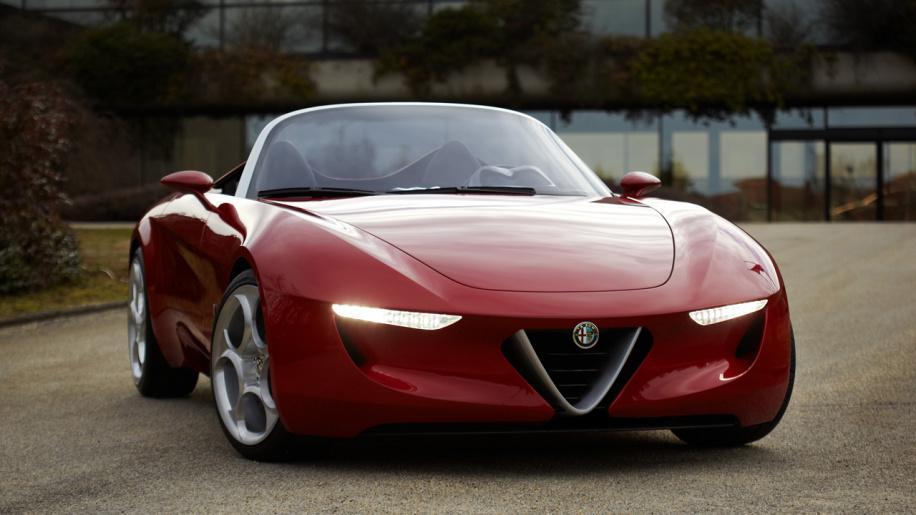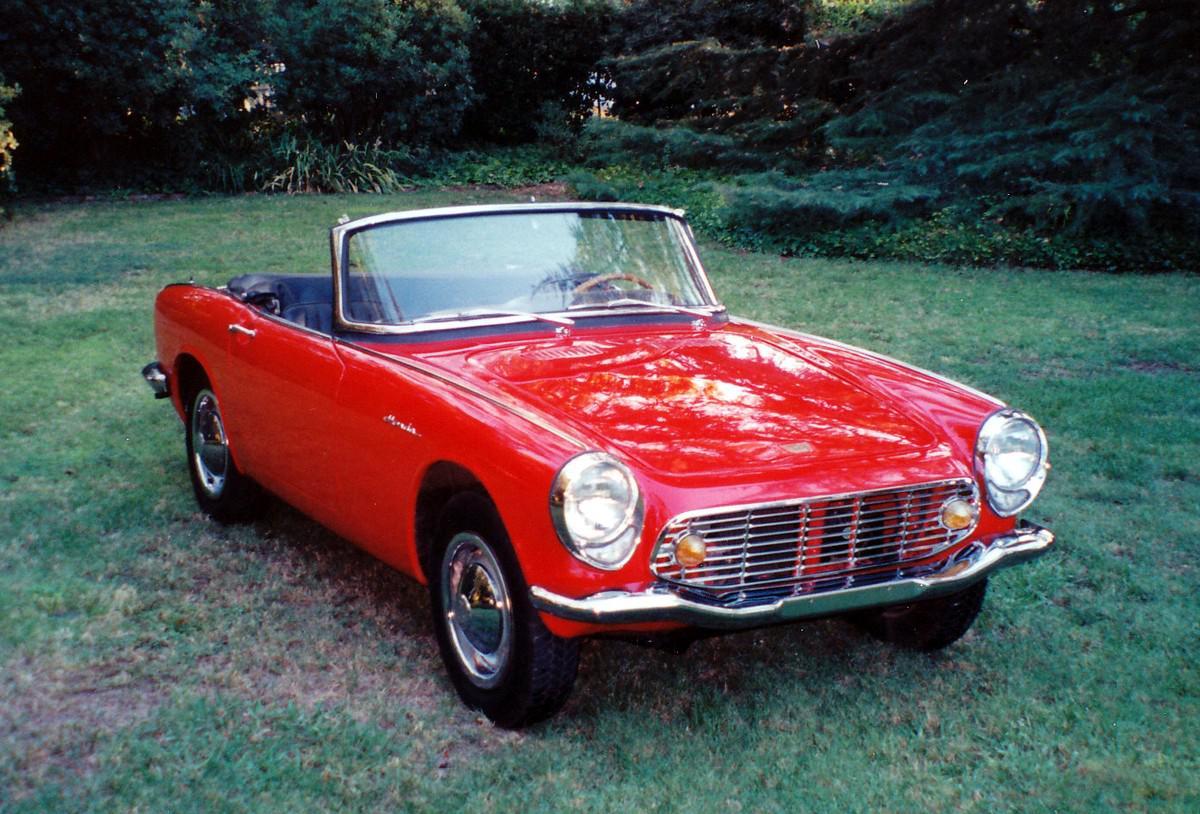The first image is the image on the left, the second image is the image on the right. For the images shown, is this caption "Two sporty red convertibles with chrome wheels are angled in different directions, only one with a front license plate and driver." true? Answer yes or no. No. The first image is the image on the left, the second image is the image on the right. Considering the images on both sides, is "The left image shows a driver behind the wheel of a topless red convertible." valid? Answer yes or no. No. 